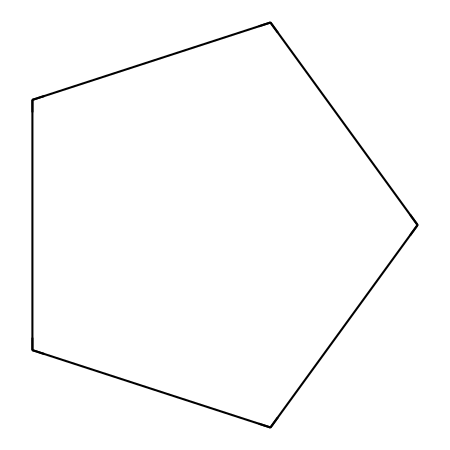What is the molecular formula for cyclopentane? The structure C1CCCC1 indicates that there are 5 carbon atoms (C) and 10 hydrogen atoms (H) connected in a ring. The molecular formula is derived from counting the number of each type of atom in the structure.
Answer: C5H10 How many carbon atoms are present in cyclopentane? The chemical structure shows a single ring of five carbon atoms, from the labeling of C1 to C5 in the SMILES representation. Therefore, counting these gives us the total number.
Answer: 5 What type of chemical structure is exhibited by cyclopentane? Cyclopentane consists of a ring structure, indicated by the cyclic notation in the SMILES (C1CCCC1), which classifies it as a cycloalkane. The presence of only single bonds between carbon atoms further supports this classification.
Answer: cycloalkane What is the total number of hydrogen atoms bonded to cyclopentane? In cyclopentane, each carbon can bond with enough hydrogen atoms to satisfy its tetravalency. Since it has 5 carbon atoms and 10 hydrogens to satisfy the bonding requirements based on its ring structure, the total count is derived from these rules.
Answer: 10 What is the hybridization of the carbon atoms in cyclopentane? Each carbon atom in cyclopentane is sp3 hybridized because they are bonded to other carbon atoms and hydrogen atoms in a tetrahedral arrangement, which is characteristic of single bonds in alkanes and cycloalkanes.
Answer: sp3 What is the stability of cyclopentane compared to other cycloalkanes? Cyclopentane has good stability due to its puckered conformation, which reduces angle strain and allows for better overlap of orbitals, making it more stable than smaller cycloalkanes like cyclobutane that have more angle strain.
Answer: more stable 